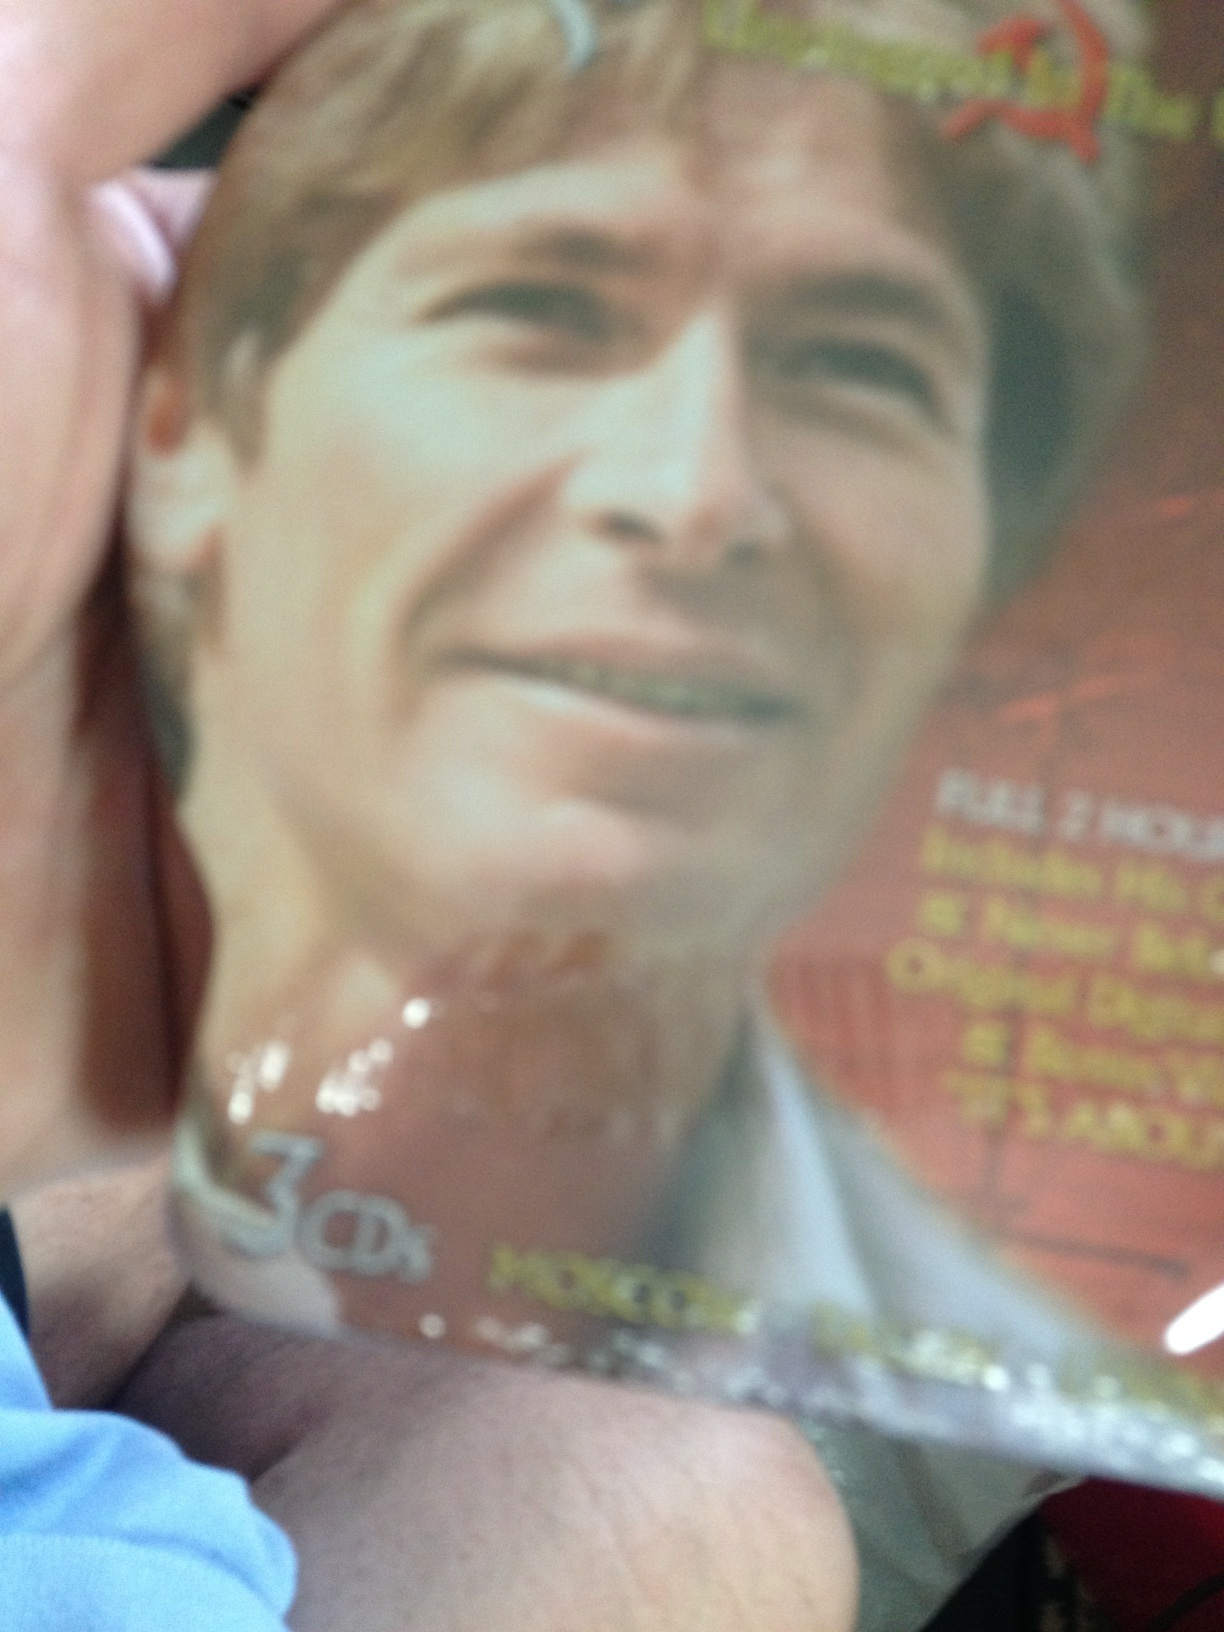How might this CD reflect the cultural context of the time it was released? This CD might reflect significant cultural elements from the time of its release, such as popular musical styles, relevant social themes, or the prevalent atmosphere in the music industry. If released during the late 20th century, for instance, it might echo the transitional trends of rock, pop, or folk music that marked that era. Predict what kind of cover art might be used if this CD were re-released today. If re-released today, the cover art for this CD might feature a modern, minimalist design with bold colors and clean lines, focusing on a striking image of the artist. The contemporary style could include digital enhancements, symbolizing a fusion of classic appeal with modern elements, aligning with current aesthetic trends in music album designs. 